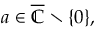Convert formula to latex. <formula><loc_0><loc_0><loc_500><loc_500>a \in { \overline { { \mathbb { C } } } } \ \{ 0 \} ,</formula> 